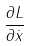Convert formula to latex. <formula><loc_0><loc_0><loc_500><loc_500>\frac { \partial L } { \partial \dot { x } }</formula> 